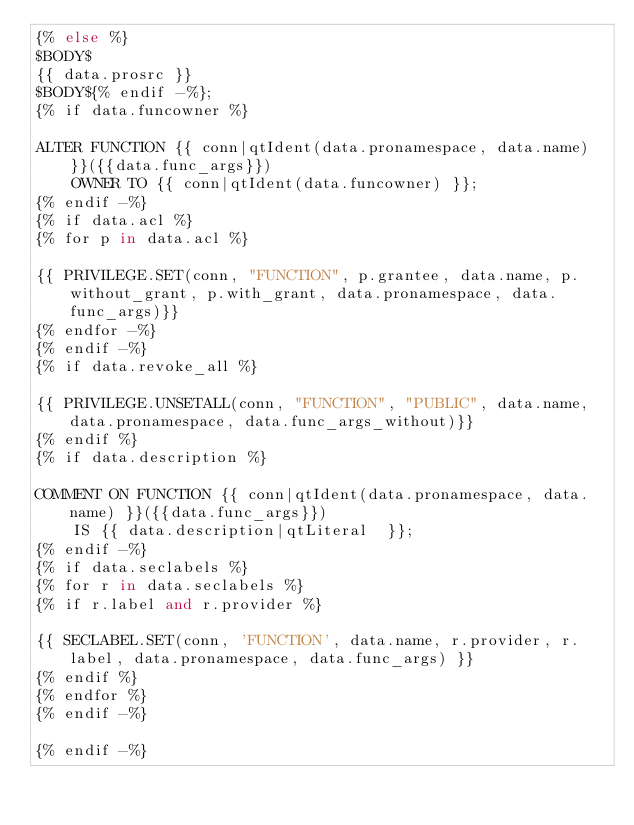<code> <loc_0><loc_0><loc_500><loc_500><_SQL_>{% else %}
$BODY$
{{ data.prosrc }}
$BODY${% endif -%};
{% if data.funcowner %}

ALTER FUNCTION {{ conn|qtIdent(data.pronamespace, data.name) }}({{data.func_args}})
    OWNER TO {{ conn|qtIdent(data.funcowner) }};
{% endif -%}
{% if data.acl %}
{% for p in data.acl %}

{{ PRIVILEGE.SET(conn, "FUNCTION", p.grantee, data.name, p.without_grant, p.with_grant, data.pronamespace, data.func_args)}}
{% endfor -%}
{% endif -%}
{% if data.revoke_all %}

{{ PRIVILEGE.UNSETALL(conn, "FUNCTION", "PUBLIC", data.name, data.pronamespace, data.func_args_without)}}
{% endif %}
{% if data.description %}

COMMENT ON FUNCTION {{ conn|qtIdent(data.pronamespace, data.name) }}({{data.func_args}})
    IS {{ data.description|qtLiteral  }};
{% endif -%}
{% if data.seclabels %}
{% for r in data.seclabels %}
{% if r.label and r.provider %}

{{ SECLABEL.SET(conn, 'FUNCTION', data.name, r.provider, r.label, data.pronamespace, data.func_args) }}
{% endif %}
{% endfor %}
{% endif -%}

{% endif -%}
</code> 